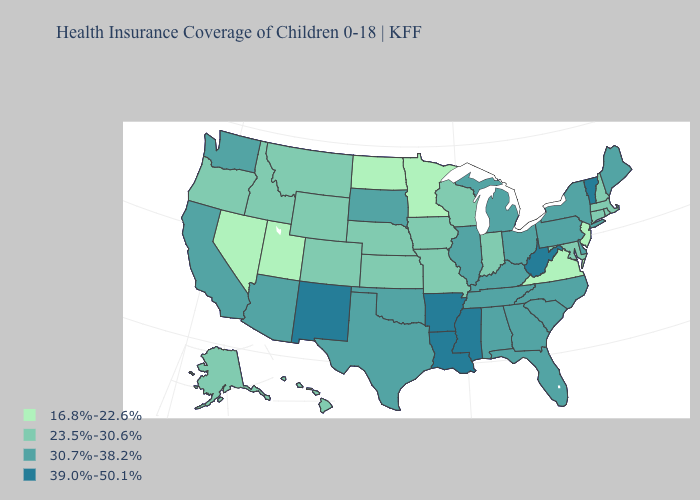Does the map have missing data?
Be succinct. No. Name the states that have a value in the range 16.8%-22.6%?
Keep it brief. Minnesota, Nevada, New Jersey, North Dakota, Utah, Virginia. Does California have the lowest value in the USA?
Answer briefly. No. Name the states that have a value in the range 23.5%-30.6%?
Short answer required. Alaska, Colorado, Connecticut, Hawaii, Idaho, Indiana, Iowa, Kansas, Maryland, Massachusetts, Missouri, Montana, Nebraska, New Hampshire, Oregon, Rhode Island, Wisconsin, Wyoming. What is the value of Idaho?
Concise answer only. 23.5%-30.6%. What is the highest value in states that border Kansas?
Be succinct. 30.7%-38.2%. Name the states that have a value in the range 30.7%-38.2%?
Give a very brief answer. Alabama, Arizona, California, Delaware, Florida, Georgia, Illinois, Kentucky, Maine, Michigan, New York, North Carolina, Ohio, Oklahoma, Pennsylvania, South Carolina, South Dakota, Tennessee, Texas, Washington. How many symbols are there in the legend?
Answer briefly. 4. What is the value of Montana?
Give a very brief answer. 23.5%-30.6%. Name the states that have a value in the range 23.5%-30.6%?
Write a very short answer. Alaska, Colorado, Connecticut, Hawaii, Idaho, Indiana, Iowa, Kansas, Maryland, Massachusetts, Missouri, Montana, Nebraska, New Hampshire, Oregon, Rhode Island, Wisconsin, Wyoming. Name the states that have a value in the range 30.7%-38.2%?
Quick response, please. Alabama, Arizona, California, Delaware, Florida, Georgia, Illinois, Kentucky, Maine, Michigan, New York, North Carolina, Ohio, Oklahoma, Pennsylvania, South Carolina, South Dakota, Tennessee, Texas, Washington. What is the lowest value in states that border Minnesota?
Write a very short answer. 16.8%-22.6%. Which states have the highest value in the USA?
Give a very brief answer. Arkansas, Louisiana, Mississippi, New Mexico, Vermont, West Virginia. 